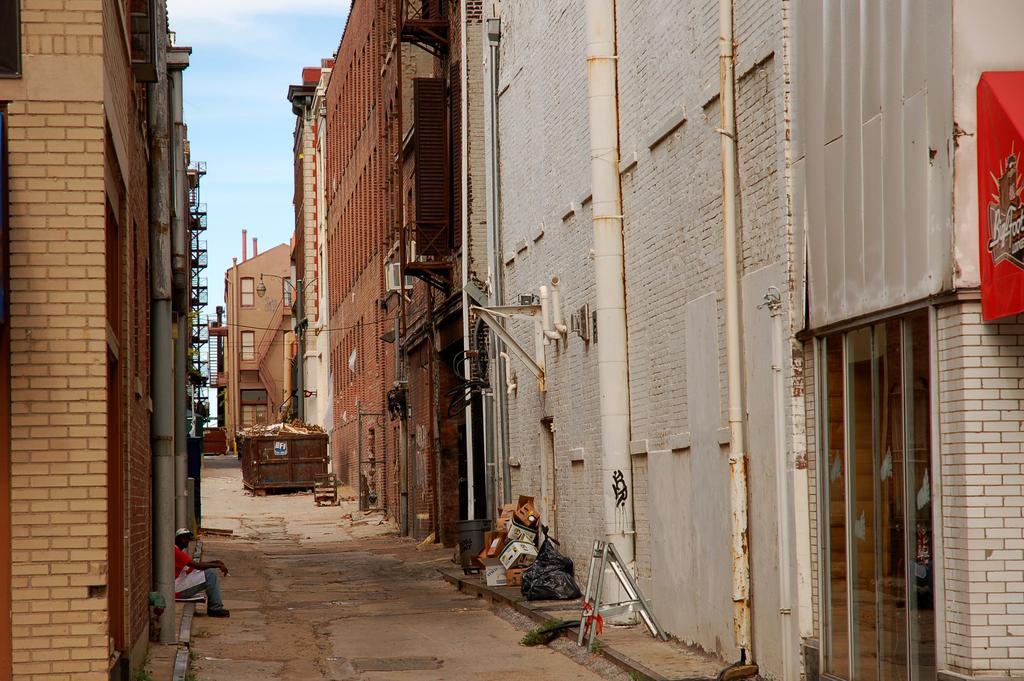In one or two sentences, can you explain what this image depicts? In the image we can see there are many buildings. These are the pipes, there are even boxes and a stand. This is a footpath, trash bin and a pale blue sky. There is a person sitting wearing clothes, shoes and a cap. 